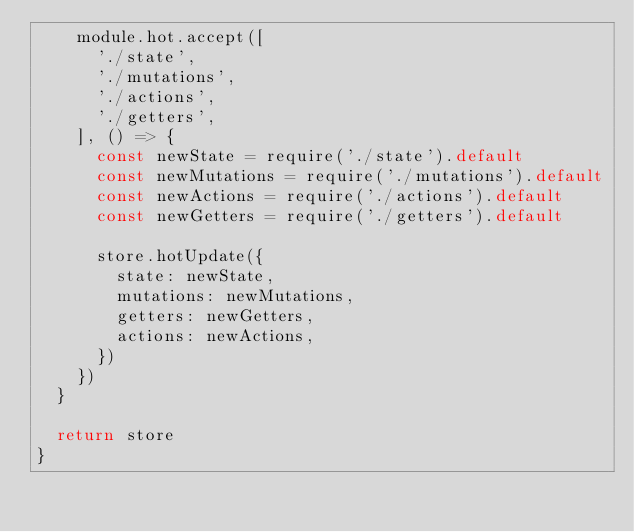<code> <loc_0><loc_0><loc_500><loc_500><_JavaScript_>    module.hot.accept([
      './state',
      './mutations',
      './actions',
      './getters',
    ], () => {
      const newState = require('./state').default
      const newMutations = require('./mutations').default
      const newActions = require('./actions').default
      const newGetters = require('./getters').default

      store.hotUpdate({
        state: newState,
        mutations: newMutations,
        getters: newGetters,
        actions: newActions,
      })
    })
  }

  return store
}
</code> 